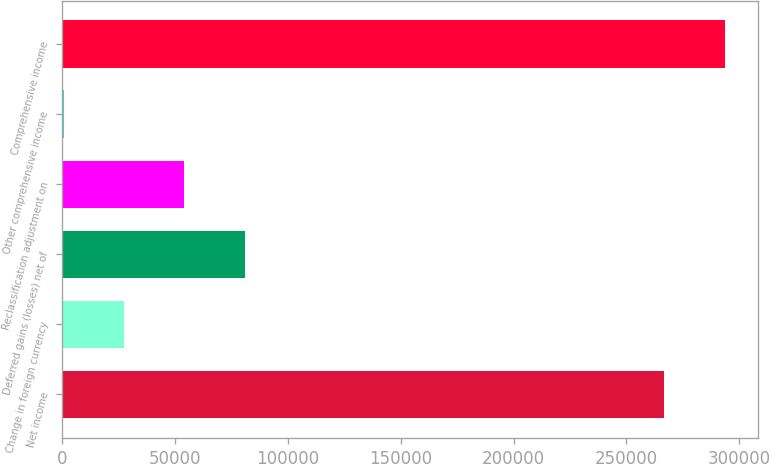<chart> <loc_0><loc_0><loc_500><loc_500><bar_chart><fcel>Net income<fcel>Change in foreign currency<fcel>Deferred gains (losses) net of<fcel>Reclassification adjustment on<fcel>Other comprehensive income<fcel>Comprehensive income<nl><fcel>266826<fcel>27480.6<fcel>80845.8<fcel>54163.2<fcel>798<fcel>293509<nl></chart> 